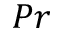<formula> <loc_0><loc_0><loc_500><loc_500>P r</formula> 